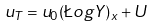Convert formula to latex. <formula><loc_0><loc_0><loc_500><loc_500>u _ { T } = u _ { 0 } ( \L o g Y ) _ { x } + U</formula> 